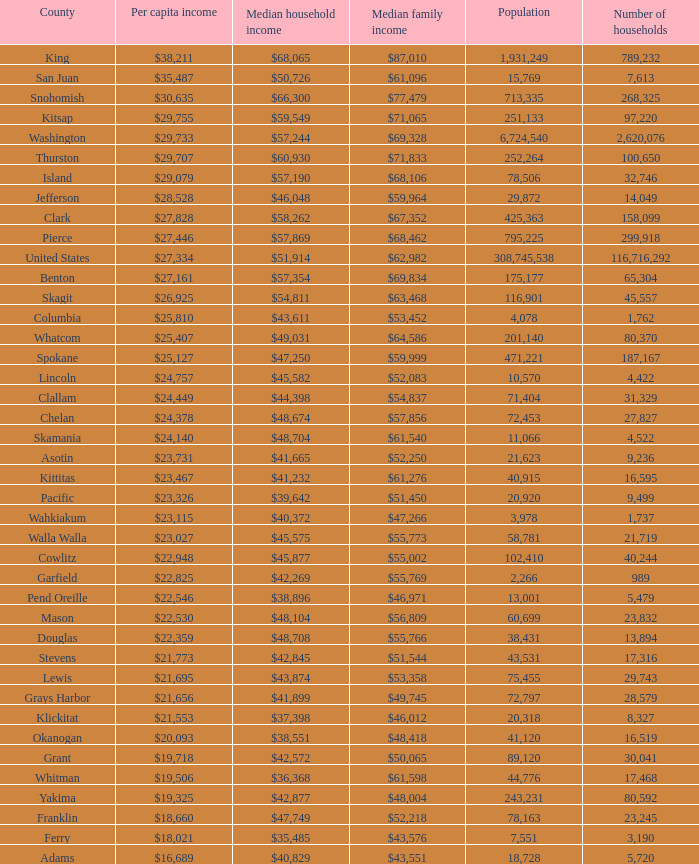How much is per capita income when median household income is $42,845? $21,773. 